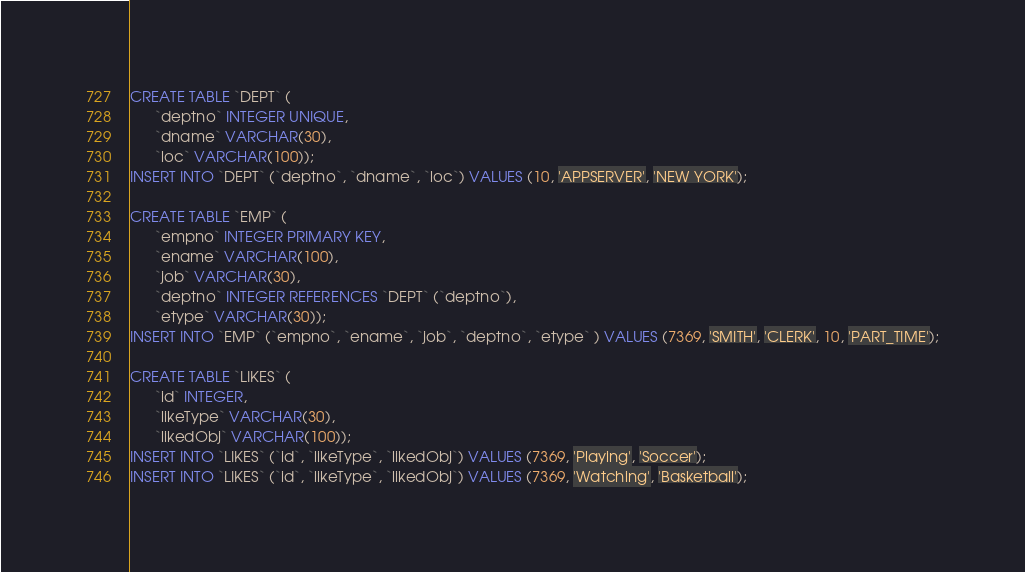<code> <loc_0><loc_0><loc_500><loc_500><_SQL_>CREATE TABLE `DEPT` (
      `deptno` INTEGER UNIQUE,
      `dname` VARCHAR(30),
      `loc` VARCHAR(100));
INSERT INTO `DEPT` (`deptno`, `dname`, `loc`) VALUES (10, 'APPSERVER', 'NEW YORK');

CREATE TABLE `EMP` (
      `empno` INTEGER PRIMARY KEY,
      `ename` VARCHAR(100),
      `job` VARCHAR(30),
	  `deptno` INTEGER REFERENCES `DEPT` (`deptno`),
	  `etype` VARCHAR(30));
INSERT INTO `EMP` (`empno`, `ename`, `job`, `deptno`, `etype` ) VALUES (7369, 'SMITH', 'CLERK', 10, 'PART_TIME');

CREATE TABLE `LIKES` (
      `id` INTEGER,
      `likeType` VARCHAR(30),
      `likedObj` VARCHAR(100));
INSERT INTO `LIKES` (`id`, `likeType`, `likedObj`) VALUES (7369, 'Playing', 'Soccer');
INSERT INTO `LIKES` (`id`, `likeType`, `likedObj`) VALUES (7369, 'Watching', 'Basketball');</code> 